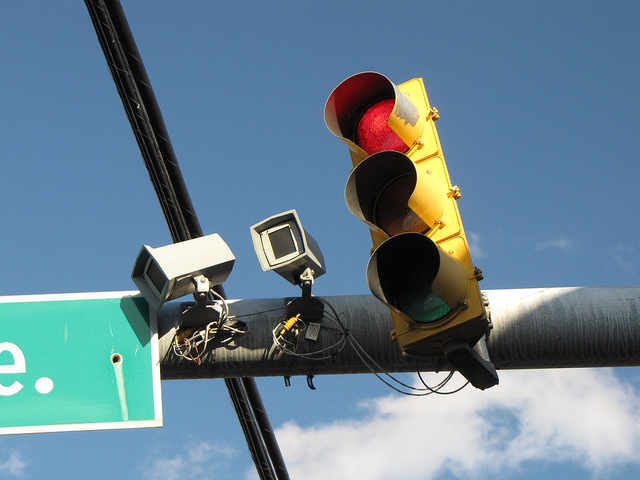Can you tell me about the additional devices attached to the traffic signal? The traffic signal has two attached devices which appear to be cameras or sensors. These might be used for monitoring traffic flow, enforcing traffic laws, or controlling the signal lights based on real-time traffic conditions. Could they serve any other purposes? Potentially, such devices could also gather data for traffic studies or be part of a larger smart city infrastructure to optimize traffic management and improve public safety. 